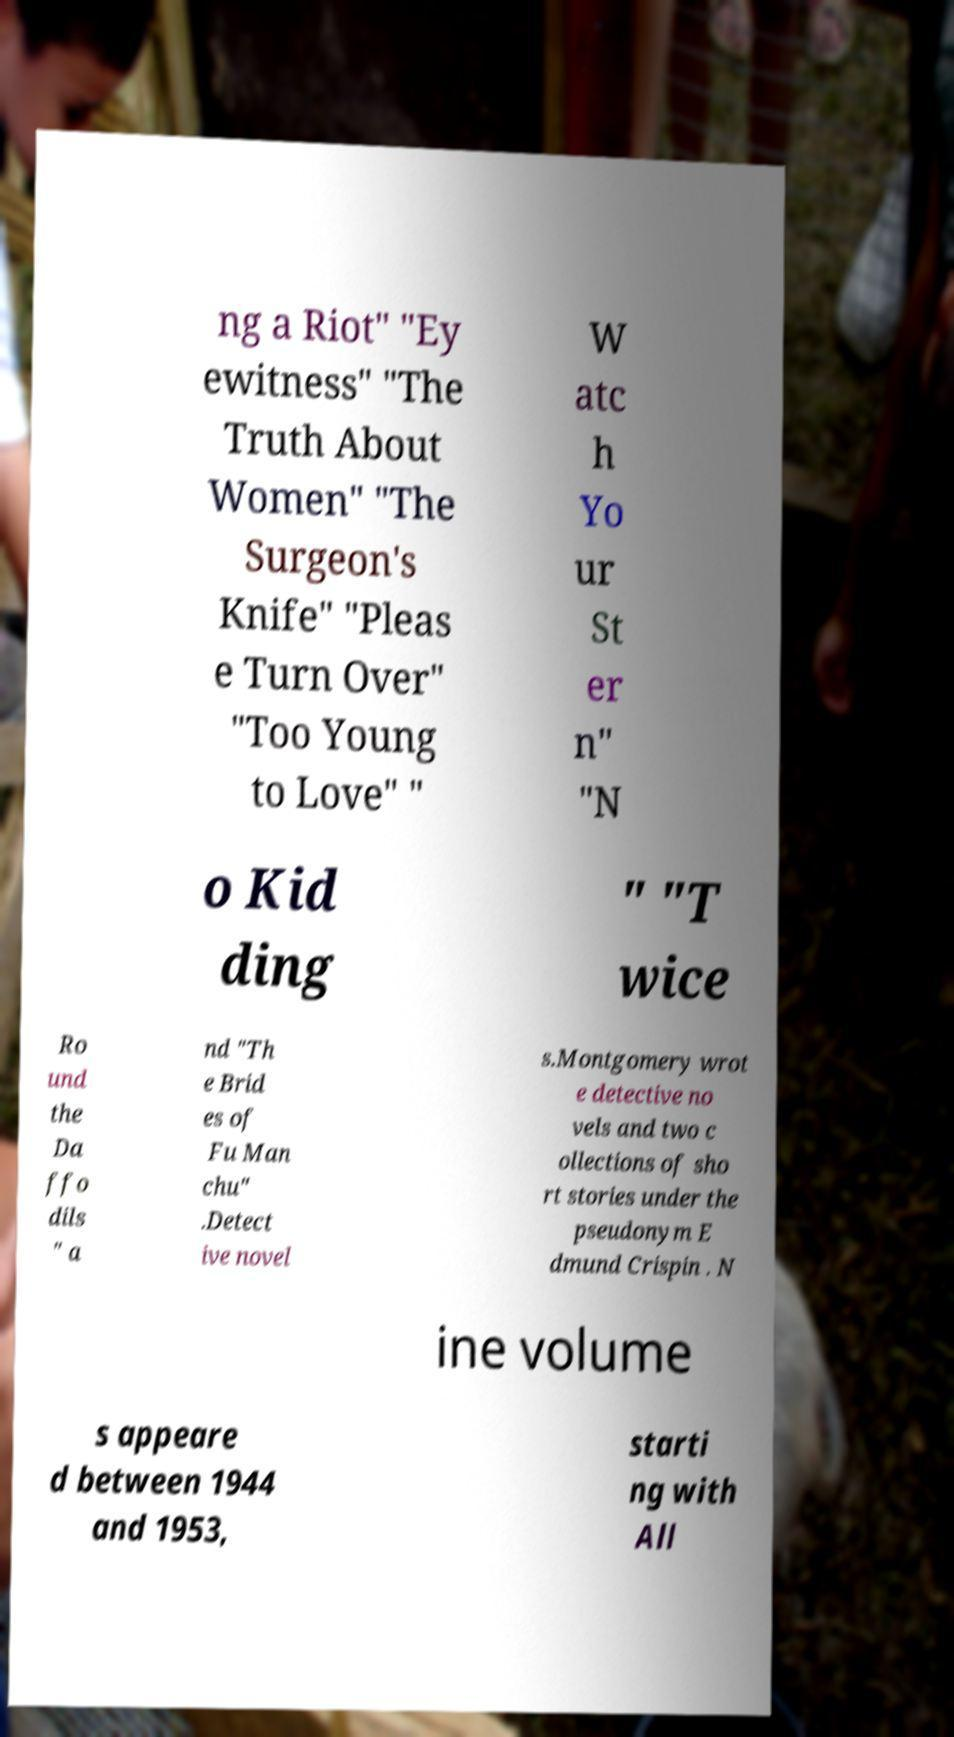What messages or text are displayed in this image? I need them in a readable, typed format. ng a Riot" "Ey ewitness" "The Truth About Women" "The Surgeon's Knife" "Pleas e Turn Over" "Too Young to Love" " W atc h Yo ur St er n" "N o Kid ding " "T wice Ro und the Da ffo dils " a nd "Th e Brid es of Fu Man chu" .Detect ive novel s.Montgomery wrot e detective no vels and two c ollections of sho rt stories under the pseudonym E dmund Crispin . N ine volume s appeare d between 1944 and 1953, starti ng with All 